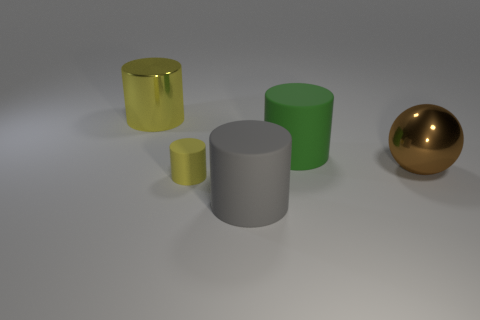Subtract all gray cubes. How many yellow cylinders are left? 2 Subtract all large yellow cylinders. How many cylinders are left? 3 Subtract 1 cylinders. How many cylinders are left? 3 Add 4 big metallic cylinders. How many objects exist? 9 Subtract all blue cylinders. Subtract all cyan balls. How many cylinders are left? 4 Subtract all spheres. How many objects are left? 4 Subtract 0 brown blocks. How many objects are left? 5 Subtract all matte cylinders. Subtract all gray objects. How many objects are left? 1 Add 4 brown shiny spheres. How many brown shiny spheres are left? 5 Add 1 large brown things. How many large brown things exist? 2 